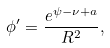Convert formula to latex. <formula><loc_0><loc_0><loc_500><loc_500>\phi ^ { \prime } = \frac { e ^ { \psi - \nu + a } } { R ^ { 2 } } ,</formula> 